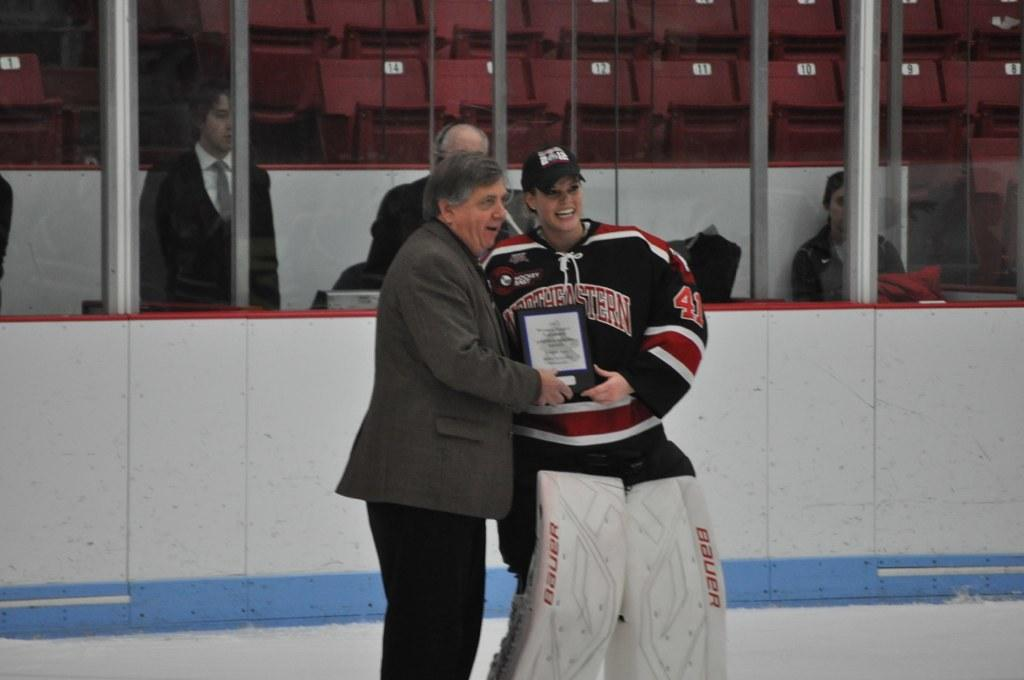What is happening in the center of the image? There are persons standing in the center of the image. What is the surface on which the persons are standing? The persons are standing on the ground. Can you describe the background of the image? There are persons visible in the background of the image, along with glass and chairs. What type of reaction can be seen in the society depicted in the image? There is no indication of a society or any reactions in the image; it simply shows persons standing on the ground and other elements in the background. 